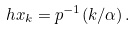<formula> <loc_0><loc_0><loc_500><loc_500>\ h x _ { k } = p ^ { - 1 } ( k / \alpha ) \, .</formula> 